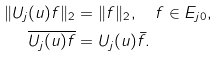Convert formula to latex. <formula><loc_0><loc_0><loc_500><loc_500>\| U _ { j } ( u ) f \| _ { 2 } & = \| f \| _ { 2 } , \quad f \in E _ { j 0 } , \\ \overline { U _ { j } ( u ) f } & = U _ { j } ( u ) \bar { f } .</formula> 